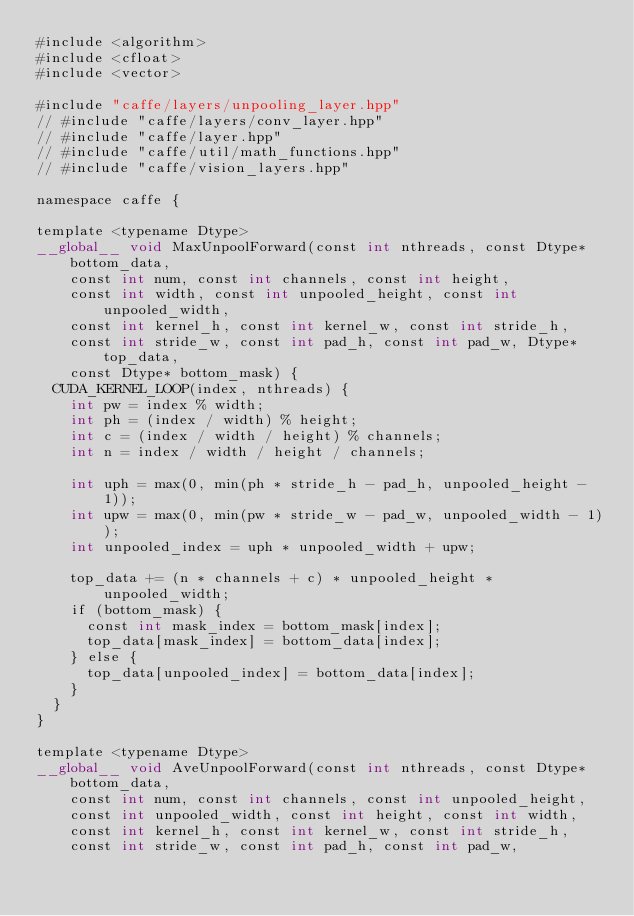Convert code to text. <code><loc_0><loc_0><loc_500><loc_500><_Cuda_>#include <algorithm>
#include <cfloat>
#include <vector>

#include "caffe/layers/unpooling_layer.hpp"
// #include "caffe/layers/conv_layer.hpp"
// #include "caffe/layer.hpp"
// #include "caffe/util/math_functions.hpp"
// #include "caffe/vision_layers.hpp"

namespace caffe {

template <typename Dtype>
__global__ void MaxUnpoolForward(const int nthreads, const Dtype* bottom_data,
    const int num, const int channels, const int height,
    const int width, const int unpooled_height, const int unpooled_width,
    const int kernel_h, const int kernel_w, const int stride_h,
    const int stride_w, const int pad_h, const int pad_w, Dtype* top_data,
    const Dtype* bottom_mask) {
  CUDA_KERNEL_LOOP(index, nthreads) {
    int pw = index % width;
    int ph = (index / width) % height;
    int c = (index / width / height) % channels;
    int n = index / width / height / channels;

    int uph = max(0, min(ph * stride_h - pad_h, unpooled_height - 1));
    int upw = max(0, min(pw * stride_w - pad_w, unpooled_width - 1));
    int unpooled_index = uph * unpooled_width + upw;

    top_data += (n * channels + c) * unpooled_height * unpooled_width;
    if (bottom_mask) {
      const int mask_index = bottom_mask[index];
      top_data[mask_index] = bottom_data[index];
    } else {
      top_data[unpooled_index] = bottom_data[index];
    }
  }
}

template <typename Dtype>
__global__ void AveUnpoolForward(const int nthreads, const Dtype* bottom_data,
    const int num, const int channels, const int unpooled_height,
    const int unpooled_width, const int height, const int width,
    const int kernel_h, const int kernel_w, const int stride_h,
    const int stride_w, const int pad_h, const int pad_w,</code> 